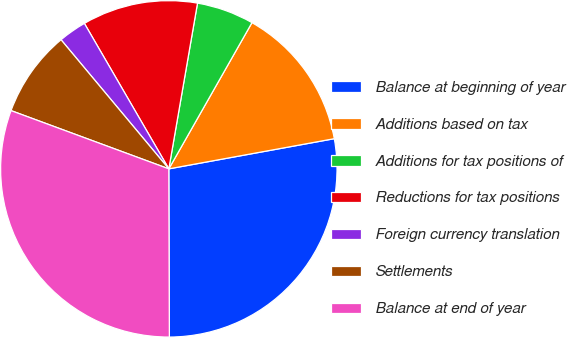Convert chart. <chart><loc_0><loc_0><loc_500><loc_500><pie_chart><fcel>Balance at beginning of year<fcel>Additions based on tax<fcel>Additions for tax positions of<fcel>Reductions for tax positions<fcel>Foreign currency translation<fcel>Settlements<fcel>Balance at end of year<nl><fcel>27.82%<fcel>13.9%<fcel>5.5%<fcel>11.1%<fcel>2.7%<fcel>8.3%<fcel>30.68%<nl></chart> 